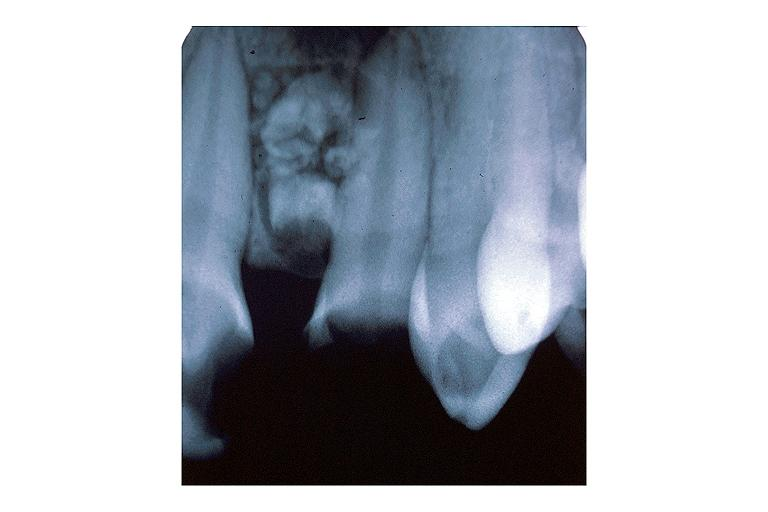s lupus erythematosus periarterial fibrosis present?
Answer the question using a single word or phrase. No 